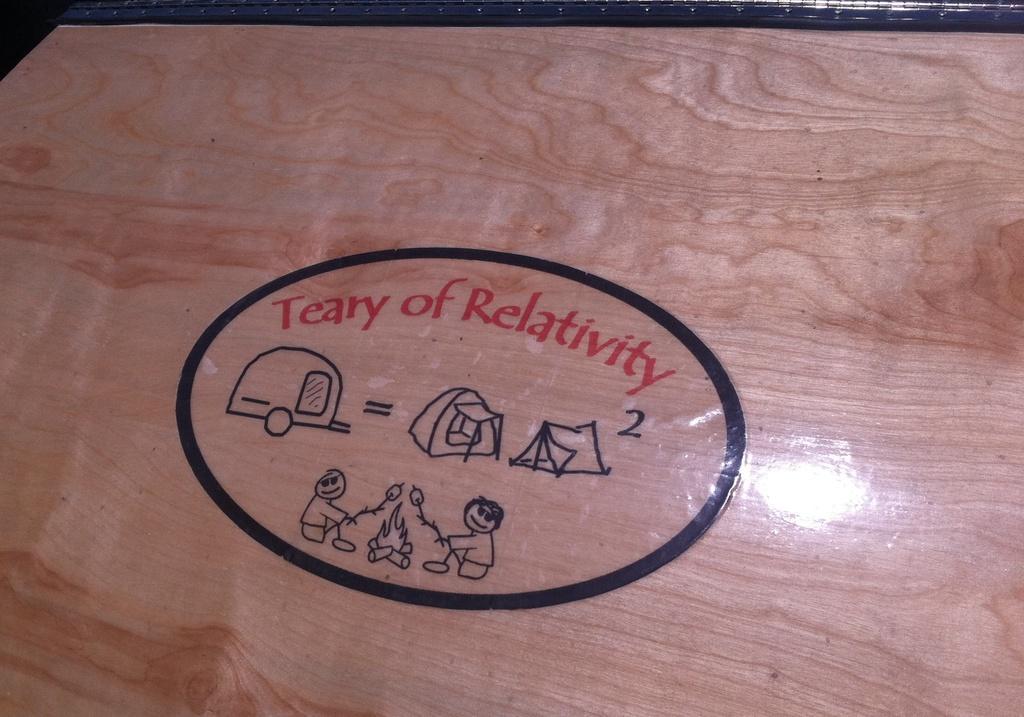How would you summarize this image in a sentence or two? In this image there is a wooden plank. In the center there is text on the plank. There are images of tents, a vehicle, two persons and fire. 